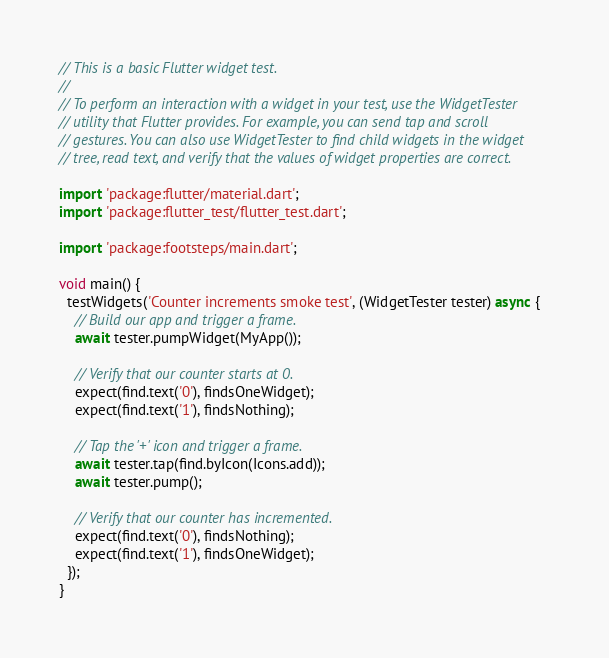Convert code to text. <code><loc_0><loc_0><loc_500><loc_500><_Dart_>// This is a basic Flutter widget test.
//
// To perform an interaction with a widget in your test, use the WidgetTester
// utility that Flutter provides. For example, you can send tap and scroll
// gestures. You can also use WidgetTester to find child widgets in the widget
// tree, read text, and verify that the values of widget properties are correct.

import 'package:flutter/material.dart';
import 'package:flutter_test/flutter_test.dart';

import 'package:footsteps/main.dart';

void main() {
  testWidgets('Counter increments smoke test', (WidgetTester tester) async {
    // Build our app and trigger a frame.
    await tester.pumpWidget(MyApp());

    // Verify that our counter starts at 0.
    expect(find.text('0'), findsOneWidget);
    expect(find.text('1'), findsNothing);

    // Tap the '+' icon and trigger a frame.
    await tester.tap(find.byIcon(Icons.add));
    await tester.pump();

    // Verify that our counter has incremented.
    expect(find.text('0'), findsNothing);
    expect(find.text('1'), findsOneWidget);
  });
}
</code> 